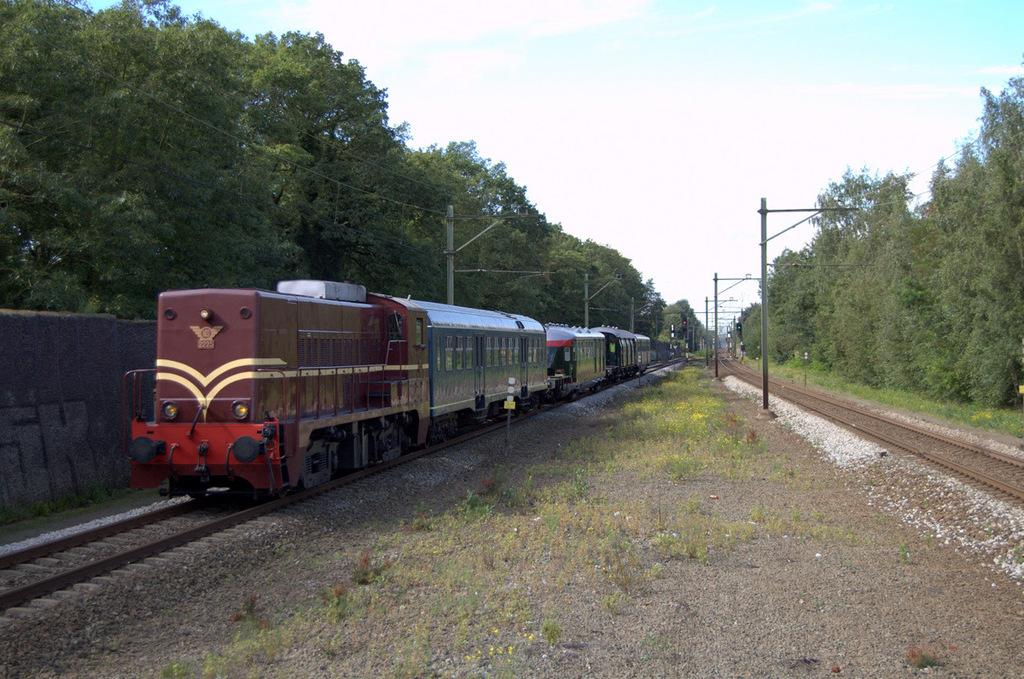What can be seen in the sky in the image? The sky with clouds is visible in the image. What type of vegetation is present in the image? There are trees in the image. What structures are related to electricity in the image? Electric poles and electric cables are present in the image. What type of ground surface is visible in the image? Grass and stones are visible in the image. What mode of transportation can be seen in the image? There is a train on a railway track in the image. How many secretaries are sitting on the train in the image? There are no secretaries present in the image; it features a train on a railway track. What type of dogs can be seen playing with the stones in the image? There are no dogs present in the image; it features stones and a train on a railway track. 